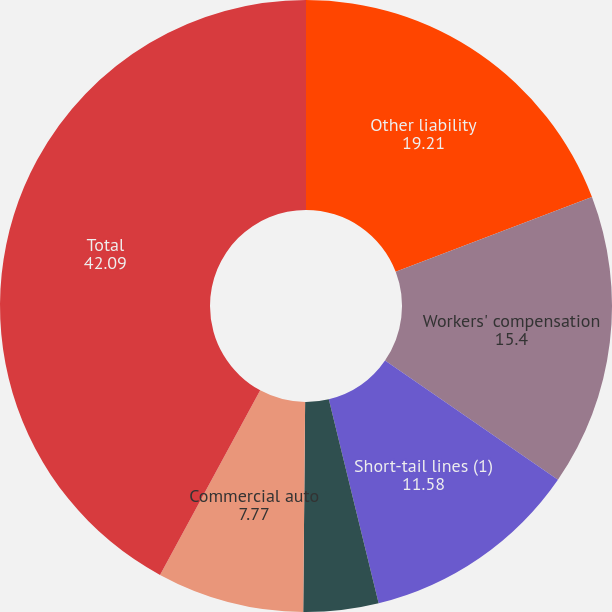Convert chart to OTSL. <chart><loc_0><loc_0><loc_500><loc_500><pie_chart><fcel>Other liability<fcel>Workers' compensation<fcel>Short-tail lines (1)<fcel>Professional liability<fcel>Commercial auto<fcel>Total<nl><fcel>19.21%<fcel>15.4%<fcel>11.58%<fcel>3.96%<fcel>7.77%<fcel>42.09%<nl></chart> 